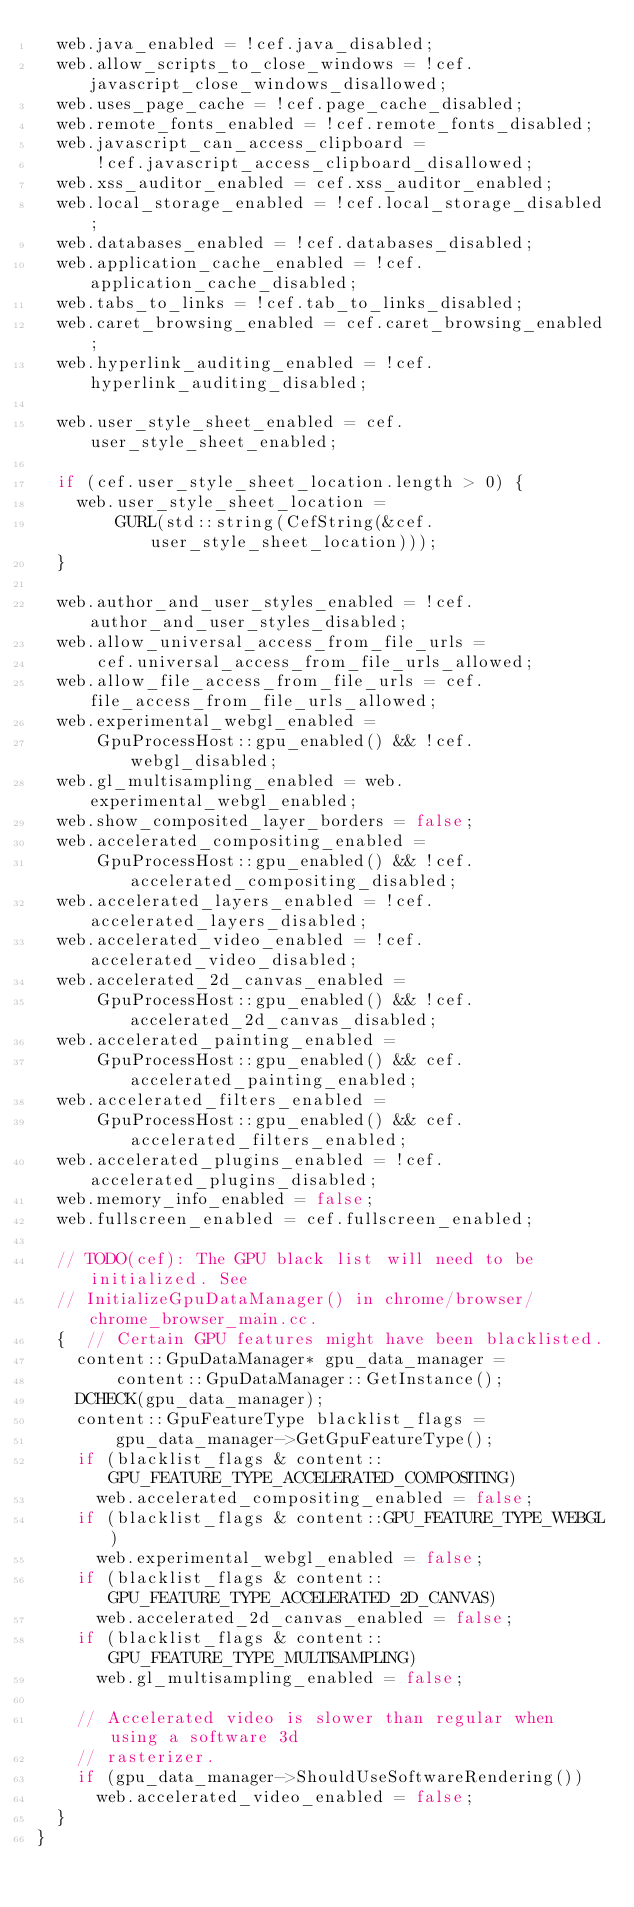<code> <loc_0><loc_0><loc_500><loc_500><_C++_>  web.java_enabled = !cef.java_disabled;
  web.allow_scripts_to_close_windows = !cef.javascript_close_windows_disallowed;
  web.uses_page_cache = !cef.page_cache_disabled;
  web.remote_fonts_enabled = !cef.remote_fonts_disabled;
  web.javascript_can_access_clipboard =
      !cef.javascript_access_clipboard_disallowed;
  web.xss_auditor_enabled = cef.xss_auditor_enabled;
  web.local_storage_enabled = !cef.local_storage_disabled;
  web.databases_enabled = !cef.databases_disabled;
  web.application_cache_enabled = !cef.application_cache_disabled;
  web.tabs_to_links = !cef.tab_to_links_disabled;
  web.caret_browsing_enabled = cef.caret_browsing_enabled;
  web.hyperlink_auditing_enabled = !cef.hyperlink_auditing_disabled;

  web.user_style_sheet_enabled = cef.user_style_sheet_enabled;

  if (cef.user_style_sheet_location.length > 0) {
    web.user_style_sheet_location =
        GURL(std::string(CefString(&cef.user_style_sheet_location)));
  }

  web.author_and_user_styles_enabled = !cef.author_and_user_styles_disabled;
  web.allow_universal_access_from_file_urls =
      cef.universal_access_from_file_urls_allowed;
  web.allow_file_access_from_file_urls = cef.file_access_from_file_urls_allowed;
  web.experimental_webgl_enabled =
      GpuProcessHost::gpu_enabled() && !cef.webgl_disabled;
  web.gl_multisampling_enabled = web.experimental_webgl_enabled;
  web.show_composited_layer_borders = false;
  web.accelerated_compositing_enabled =
      GpuProcessHost::gpu_enabled() && !cef.accelerated_compositing_disabled;
  web.accelerated_layers_enabled = !cef.accelerated_layers_disabled;
  web.accelerated_video_enabled = !cef.accelerated_video_disabled;
  web.accelerated_2d_canvas_enabled =
      GpuProcessHost::gpu_enabled() && !cef.accelerated_2d_canvas_disabled;
  web.accelerated_painting_enabled =
      GpuProcessHost::gpu_enabled() && cef.accelerated_painting_enabled;
  web.accelerated_filters_enabled =
      GpuProcessHost::gpu_enabled() && cef.accelerated_filters_enabled;
  web.accelerated_plugins_enabled = !cef.accelerated_plugins_disabled;
  web.memory_info_enabled = false;
  web.fullscreen_enabled = cef.fullscreen_enabled;

  // TODO(cef): The GPU black list will need to be initialized. See
  // InitializeGpuDataManager() in chrome/browser/chrome_browser_main.cc.
  {  // Certain GPU features might have been blacklisted.
    content::GpuDataManager* gpu_data_manager =
        content::GpuDataManager::GetInstance();
    DCHECK(gpu_data_manager);
    content::GpuFeatureType blacklist_flags =
        gpu_data_manager->GetGpuFeatureType();
    if (blacklist_flags & content::GPU_FEATURE_TYPE_ACCELERATED_COMPOSITING)
      web.accelerated_compositing_enabled = false;
    if (blacklist_flags & content::GPU_FEATURE_TYPE_WEBGL)
      web.experimental_webgl_enabled = false;
    if (blacklist_flags & content::GPU_FEATURE_TYPE_ACCELERATED_2D_CANVAS)
      web.accelerated_2d_canvas_enabled = false;
    if (blacklist_flags & content::GPU_FEATURE_TYPE_MULTISAMPLING)
      web.gl_multisampling_enabled = false;

    // Accelerated video is slower than regular when using a software 3d
    // rasterizer.
    if (gpu_data_manager->ShouldUseSoftwareRendering())
      web.accelerated_video_enabled = false;
  }
}
</code> 